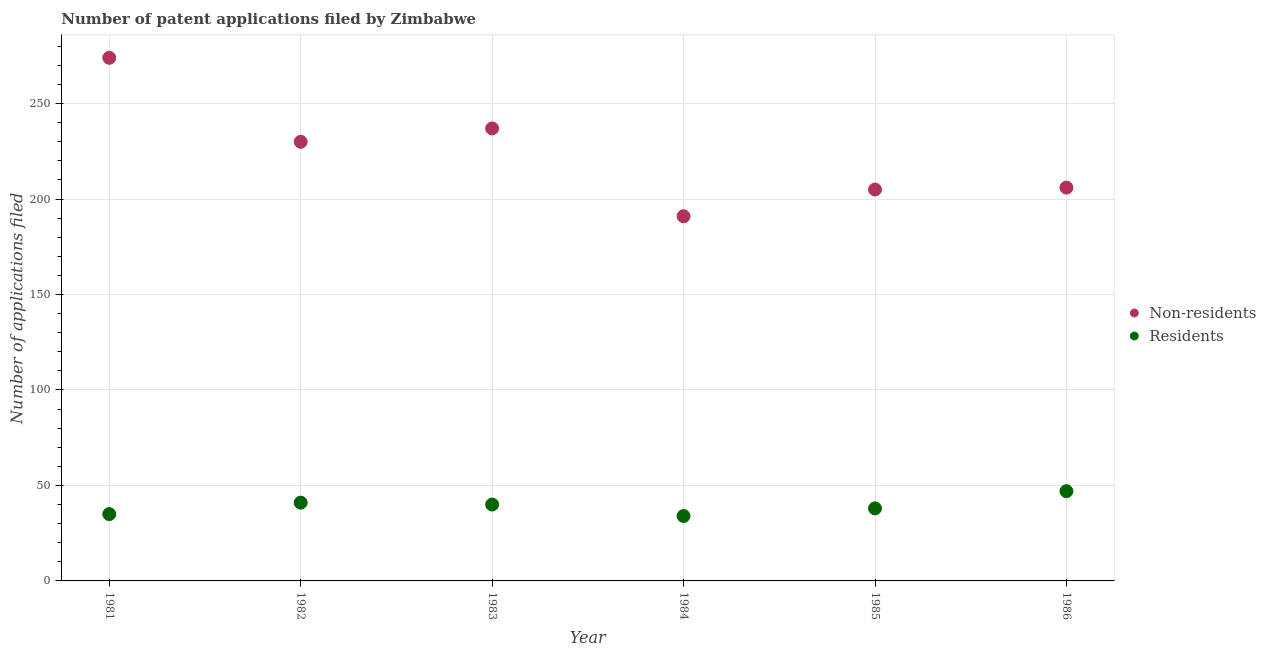How many different coloured dotlines are there?
Your answer should be very brief. 2. Is the number of dotlines equal to the number of legend labels?
Your response must be concise. Yes. What is the number of patent applications by non residents in 1983?
Ensure brevity in your answer.  237. Across all years, what is the maximum number of patent applications by non residents?
Provide a short and direct response. 274. Across all years, what is the minimum number of patent applications by residents?
Keep it short and to the point. 34. In which year was the number of patent applications by residents minimum?
Offer a terse response. 1984. What is the total number of patent applications by residents in the graph?
Keep it short and to the point. 235. What is the difference between the number of patent applications by residents in 1981 and that in 1983?
Offer a very short reply. -5. What is the difference between the number of patent applications by non residents in 1985 and the number of patent applications by residents in 1981?
Give a very brief answer. 170. What is the average number of patent applications by residents per year?
Make the answer very short. 39.17. In the year 1986, what is the difference between the number of patent applications by residents and number of patent applications by non residents?
Offer a very short reply. -159. In how many years, is the number of patent applications by residents greater than 50?
Offer a very short reply. 0. What is the ratio of the number of patent applications by non residents in 1981 to that in 1982?
Make the answer very short. 1.19. Is the number of patent applications by residents in 1981 less than that in 1983?
Your response must be concise. Yes. What is the difference between the highest and the second highest number of patent applications by residents?
Offer a terse response. 6. What is the difference between the highest and the lowest number of patent applications by residents?
Offer a terse response. 13. In how many years, is the number of patent applications by residents greater than the average number of patent applications by residents taken over all years?
Provide a short and direct response. 3. Is the number of patent applications by residents strictly greater than the number of patent applications by non residents over the years?
Give a very brief answer. No. How many dotlines are there?
Give a very brief answer. 2. How many years are there in the graph?
Offer a very short reply. 6. What is the difference between two consecutive major ticks on the Y-axis?
Keep it short and to the point. 50. Does the graph contain any zero values?
Your answer should be compact. No. Where does the legend appear in the graph?
Your answer should be very brief. Center right. How many legend labels are there?
Your answer should be compact. 2. What is the title of the graph?
Ensure brevity in your answer.  Number of patent applications filed by Zimbabwe. Does "Non-resident workers" appear as one of the legend labels in the graph?
Offer a terse response. No. What is the label or title of the X-axis?
Keep it short and to the point. Year. What is the label or title of the Y-axis?
Your answer should be very brief. Number of applications filed. What is the Number of applications filed in Non-residents in 1981?
Provide a succinct answer. 274. What is the Number of applications filed of Residents in 1981?
Your answer should be very brief. 35. What is the Number of applications filed in Non-residents in 1982?
Make the answer very short. 230. What is the Number of applications filed of Residents in 1982?
Make the answer very short. 41. What is the Number of applications filed in Non-residents in 1983?
Your answer should be compact. 237. What is the Number of applications filed in Non-residents in 1984?
Your answer should be compact. 191. What is the Number of applications filed of Non-residents in 1985?
Offer a terse response. 205. What is the Number of applications filed in Non-residents in 1986?
Your response must be concise. 206. What is the Number of applications filed in Residents in 1986?
Make the answer very short. 47. Across all years, what is the maximum Number of applications filed of Non-residents?
Offer a very short reply. 274. Across all years, what is the maximum Number of applications filed of Residents?
Your response must be concise. 47. Across all years, what is the minimum Number of applications filed in Non-residents?
Ensure brevity in your answer.  191. Across all years, what is the minimum Number of applications filed of Residents?
Provide a succinct answer. 34. What is the total Number of applications filed of Non-residents in the graph?
Your answer should be compact. 1343. What is the total Number of applications filed in Residents in the graph?
Give a very brief answer. 235. What is the difference between the Number of applications filed of Non-residents in 1981 and that in 1982?
Provide a short and direct response. 44. What is the difference between the Number of applications filed in Residents in 1981 and that in 1982?
Provide a short and direct response. -6. What is the difference between the Number of applications filed of Residents in 1981 and that in 1983?
Give a very brief answer. -5. What is the difference between the Number of applications filed of Residents in 1981 and that in 1984?
Offer a very short reply. 1. What is the difference between the Number of applications filed in Non-residents in 1981 and that in 1985?
Ensure brevity in your answer.  69. What is the difference between the Number of applications filed of Residents in 1981 and that in 1986?
Provide a short and direct response. -12. What is the difference between the Number of applications filed of Residents in 1982 and that in 1983?
Provide a short and direct response. 1. What is the difference between the Number of applications filed in Non-residents in 1982 and that in 1985?
Offer a very short reply. 25. What is the difference between the Number of applications filed of Residents in 1982 and that in 1986?
Provide a succinct answer. -6. What is the difference between the Number of applications filed of Residents in 1983 and that in 1986?
Provide a succinct answer. -7. What is the difference between the Number of applications filed in Non-residents in 1984 and that in 1986?
Give a very brief answer. -15. What is the difference between the Number of applications filed of Residents in 1984 and that in 1986?
Give a very brief answer. -13. What is the difference between the Number of applications filed of Residents in 1985 and that in 1986?
Your answer should be very brief. -9. What is the difference between the Number of applications filed in Non-residents in 1981 and the Number of applications filed in Residents in 1982?
Make the answer very short. 233. What is the difference between the Number of applications filed of Non-residents in 1981 and the Number of applications filed of Residents in 1983?
Keep it short and to the point. 234. What is the difference between the Number of applications filed in Non-residents in 1981 and the Number of applications filed in Residents in 1984?
Your answer should be compact. 240. What is the difference between the Number of applications filed in Non-residents in 1981 and the Number of applications filed in Residents in 1985?
Make the answer very short. 236. What is the difference between the Number of applications filed of Non-residents in 1981 and the Number of applications filed of Residents in 1986?
Provide a succinct answer. 227. What is the difference between the Number of applications filed in Non-residents in 1982 and the Number of applications filed in Residents in 1983?
Your answer should be very brief. 190. What is the difference between the Number of applications filed of Non-residents in 1982 and the Number of applications filed of Residents in 1984?
Provide a succinct answer. 196. What is the difference between the Number of applications filed of Non-residents in 1982 and the Number of applications filed of Residents in 1985?
Provide a succinct answer. 192. What is the difference between the Number of applications filed in Non-residents in 1982 and the Number of applications filed in Residents in 1986?
Provide a short and direct response. 183. What is the difference between the Number of applications filed of Non-residents in 1983 and the Number of applications filed of Residents in 1984?
Keep it short and to the point. 203. What is the difference between the Number of applications filed in Non-residents in 1983 and the Number of applications filed in Residents in 1985?
Offer a very short reply. 199. What is the difference between the Number of applications filed of Non-residents in 1983 and the Number of applications filed of Residents in 1986?
Give a very brief answer. 190. What is the difference between the Number of applications filed in Non-residents in 1984 and the Number of applications filed in Residents in 1985?
Provide a succinct answer. 153. What is the difference between the Number of applications filed of Non-residents in 1984 and the Number of applications filed of Residents in 1986?
Offer a very short reply. 144. What is the difference between the Number of applications filed of Non-residents in 1985 and the Number of applications filed of Residents in 1986?
Keep it short and to the point. 158. What is the average Number of applications filed in Non-residents per year?
Ensure brevity in your answer.  223.83. What is the average Number of applications filed in Residents per year?
Provide a succinct answer. 39.17. In the year 1981, what is the difference between the Number of applications filed of Non-residents and Number of applications filed of Residents?
Your response must be concise. 239. In the year 1982, what is the difference between the Number of applications filed in Non-residents and Number of applications filed in Residents?
Your answer should be compact. 189. In the year 1983, what is the difference between the Number of applications filed in Non-residents and Number of applications filed in Residents?
Provide a succinct answer. 197. In the year 1984, what is the difference between the Number of applications filed of Non-residents and Number of applications filed of Residents?
Your answer should be compact. 157. In the year 1985, what is the difference between the Number of applications filed of Non-residents and Number of applications filed of Residents?
Ensure brevity in your answer.  167. In the year 1986, what is the difference between the Number of applications filed of Non-residents and Number of applications filed of Residents?
Ensure brevity in your answer.  159. What is the ratio of the Number of applications filed of Non-residents in 1981 to that in 1982?
Make the answer very short. 1.19. What is the ratio of the Number of applications filed in Residents in 1981 to that in 1982?
Offer a very short reply. 0.85. What is the ratio of the Number of applications filed in Non-residents in 1981 to that in 1983?
Make the answer very short. 1.16. What is the ratio of the Number of applications filed of Non-residents in 1981 to that in 1984?
Keep it short and to the point. 1.43. What is the ratio of the Number of applications filed in Residents in 1981 to that in 1984?
Ensure brevity in your answer.  1.03. What is the ratio of the Number of applications filed in Non-residents in 1981 to that in 1985?
Your answer should be very brief. 1.34. What is the ratio of the Number of applications filed of Residents in 1981 to that in 1985?
Make the answer very short. 0.92. What is the ratio of the Number of applications filed of Non-residents in 1981 to that in 1986?
Your answer should be very brief. 1.33. What is the ratio of the Number of applications filed in Residents in 1981 to that in 1986?
Provide a short and direct response. 0.74. What is the ratio of the Number of applications filed in Non-residents in 1982 to that in 1983?
Give a very brief answer. 0.97. What is the ratio of the Number of applications filed of Residents in 1982 to that in 1983?
Offer a very short reply. 1.02. What is the ratio of the Number of applications filed in Non-residents in 1982 to that in 1984?
Give a very brief answer. 1.2. What is the ratio of the Number of applications filed of Residents in 1982 to that in 1984?
Your answer should be compact. 1.21. What is the ratio of the Number of applications filed of Non-residents in 1982 to that in 1985?
Provide a succinct answer. 1.12. What is the ratio of the Number of applications filed in Residents in 1982 to that in 1985?
Provide a short and direct response. 1.08. What is the ratio of the Number of applications filed of Non-residents in 1982 to that in 1986?
Offer a very short reply. 1.12. What is the ratio of the Number of applications filed of Residents in 1982 to that in 1986?
Your response must be concise. 0.87. What is the ratio of the Number of applications filed in Non-residents in 1983 to that in 1984?
Provide a short and direct response. 1.24. What is the ratio of the Number of applications filed in Residents in 1983 to that in 1984?
Provide a succinct answer. 1.18. What is the ratio of the Number of applications filed in Non-residents in 1983 to that in 1985?
Offer a terse response. 1.16. What is the ratio of the Number of applications filed of Residents in 1983 to that in 1985?
Provide a succinct answer. 1.05. What is the ratio of the Number of applications filed in Non-residents in 1983 to that in 1986?
Your answer should be compact. 1.15. What is the ratio of the Number of applications filed in Residents in 1983 to that in 1986?
Give a very brief answer. 0.85. What is the ratio of the Number of applications filed in Non-residents in 1984 to that in 1985?
Your answer should be very brief. 0.93. What is the ratio of the Number of applications filed of Residents in 1984 to that in 1985?
Make the answer very short. 0.89. What is the ratio of the Number of applications filed of Non-residents in 1984 to that in 1986?
Your answer should be very brief. 0.93. What is the ratio of the Number of applications filed of Residents in 1984 to that in 1986?
Provide a succinct answer. 0.72. What is the ratio of the Number of applications filed of Non-residents in 1985 to that in 1986?
Your answer should be compact. 1. What is the ratio of the Number of applications filed of Residents in 1985 to that in 1986?
Give a very brief answer. 0.81. What is the difference between the highest and the second highest Number of applications filed of Non-residents?
Your response must be concise. 37. What is the difference between the highest and the second highest Number of applications filed of Residents?
Make the answer very short. 6. What is the difference between the highest and the lowest Number of applications filed of Non-residents?
Offer a terse response. 83. 